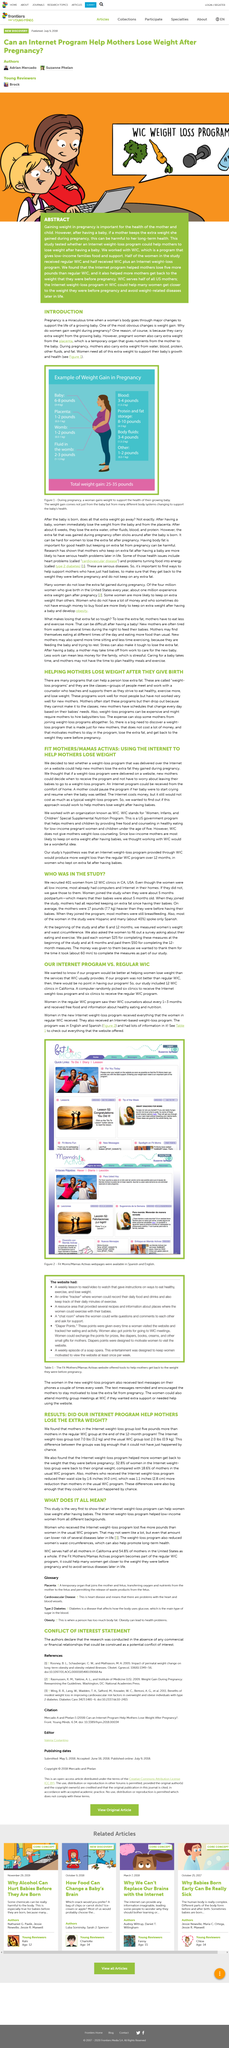Highlight a few significant elements in this photo. A total of 401 women were recruited for the study. A study compared the effectiveness of two programs in helping women lose weight after giving birth, including an internet-based weight loss program and the WIC (Women, Infants, and Children) program. The Internet weight-loss group collectively lost 7.0 pounds (3.2 kilograms). Reducing women's waist circumference can promote long-term health. The women joined the study approximately 5 months post-partum. 